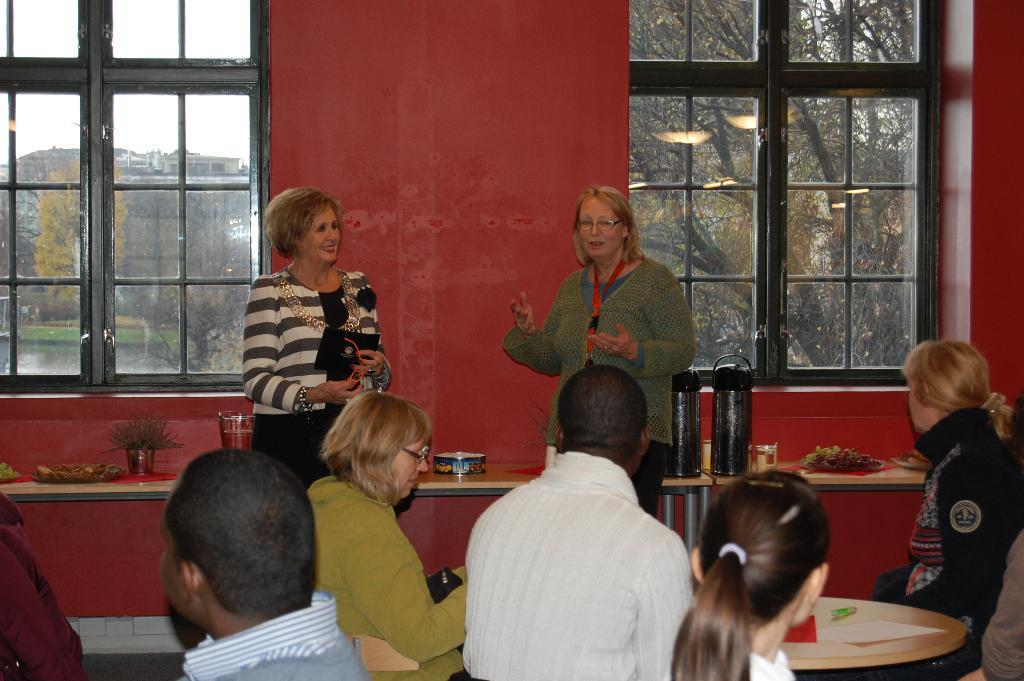What type of vegetation can be seen in the image? There are trees in the image. What architectural feature is visible in the image? There is a window in the image. What color is the wall in the image? The wall in the image is red. What are the people in the image doing? The people in the image are standing and sitting. What furniture is present in the image? There is a table in the image. What items can be seen on the table? There is a flower flask, a bowl, and a bouquet on the table. What type of loaf is being served on the table in the image? There is no loaf present on the table in the image. How many heads are visible in the image? The image does not show any heads, as it focuses on the trees, window, wall, people, table, and items on the table. 